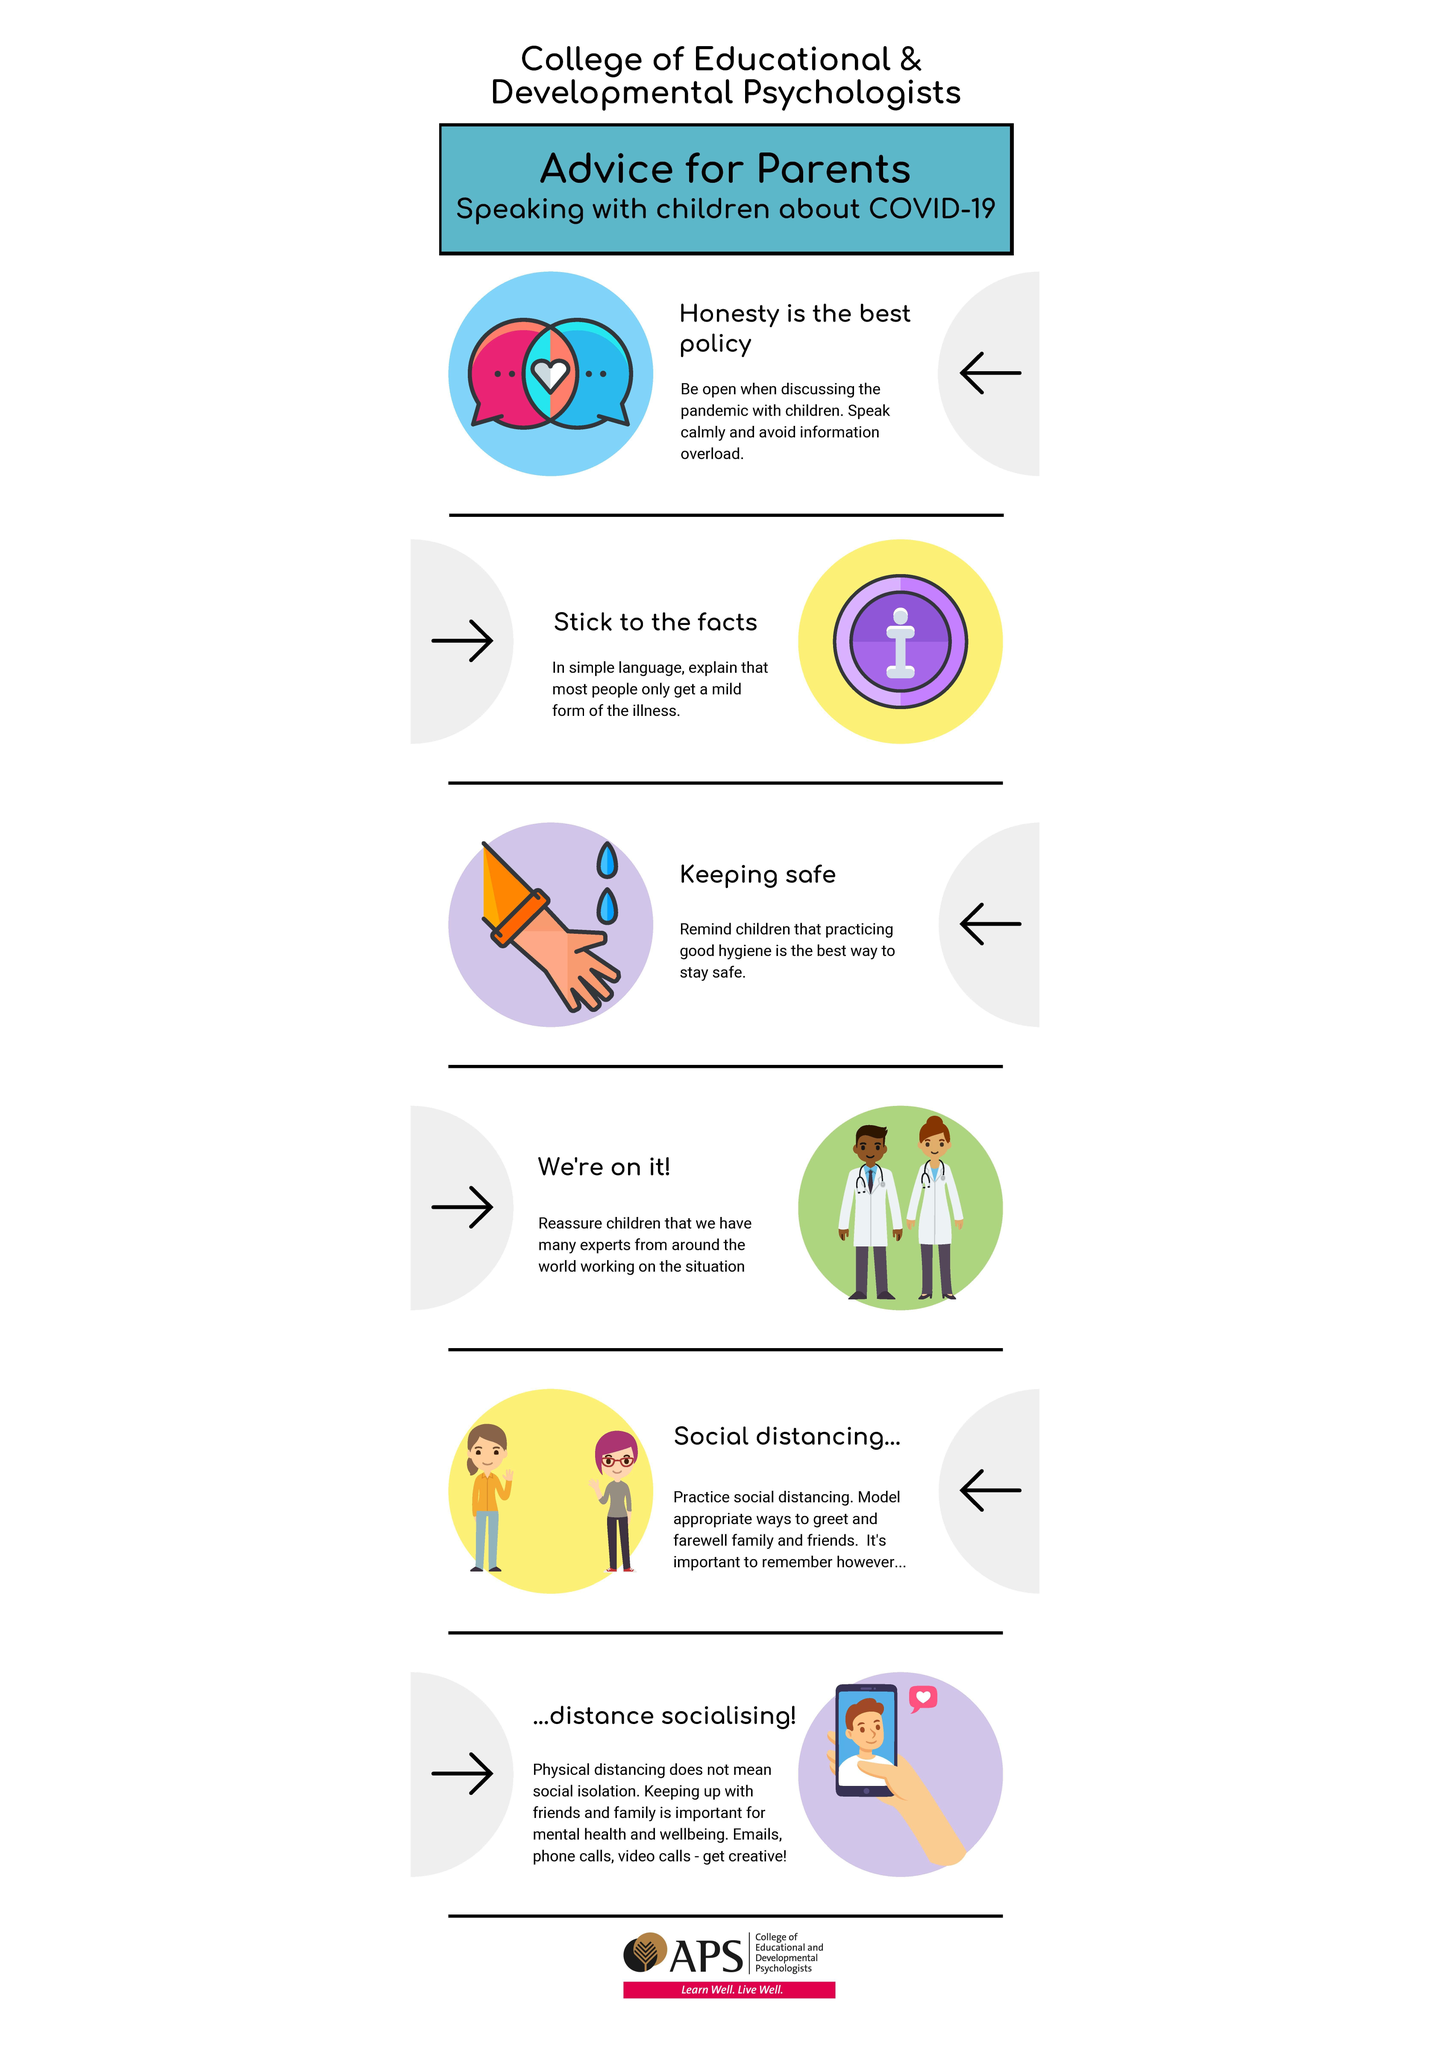Highlight a few significant elements in this photo. Preventing the spread of COVID-19 requires practicing good hygiene, which is the greatest practice to prevent corona. 